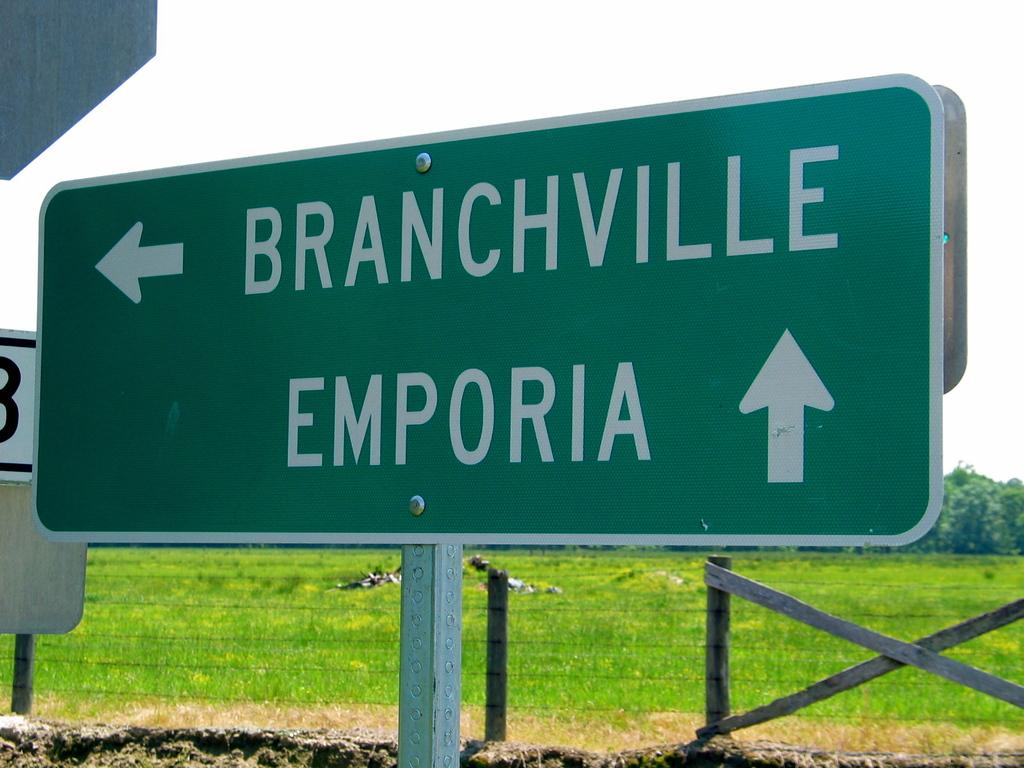<image>
Provide a brief description of the given image. A highway sign that directs those going to Branchville to the left and those going to Emporia forward. 